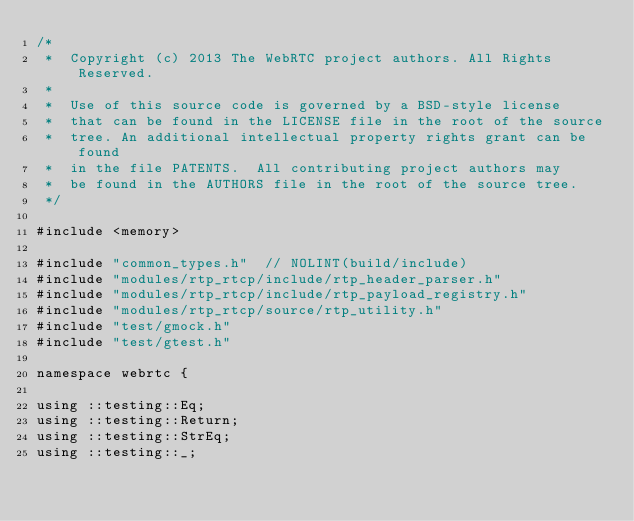<code> <loc_0><loc_0><loc_500><loc_500><_C++_>/*
 *  Copyright (c) 2013 The WebRTC project authors. All Rights Reserved.
 *
 *  Use of this source code is governed by a BSD-style license
 *  that can be found in the LICENSE file in the root of the source
 *  tree. An additional intellectual property rights grant can be found
 *  in the file PATENTS.  All contributing project authors may
 *  be found in the AUTHORS file in the root of the source tree.
 */

#include <memory>

#include "common_types.h"  // NOLINT(build/include)
#include "modules/rtp_rtcp/include/rtp_header_parser.h"
#include "modules/rtp_rtcp/include/rtp_payload_registry.h"
#include "modules/rtp_rtcp/source/rtp_utility.h"
#include "test/gmock.h"
#include "test/gtest.h"

namespace webrtc {

using ::testing::Eq;
using ::testing::Return;
using ::testing::StrEq;
using ::testing::_;
</code> 